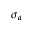<formula> <loc_0><loc_0><loc_500><loc_500>\sigma _ { a }</formula> 